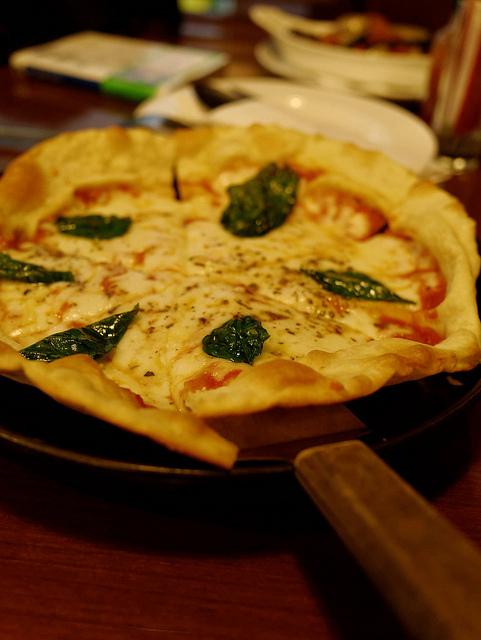Is the background in focus?
Keep it brief. No. Is there spinach on the pizza?
Concise answer only. Yes. What type of food is this?
Be succinct. Pizza. What sole topping is shown on the pizza?
Write a very short answer. Spinach. What toppings are on the pizza?
Quick response, please. Cheese. What does this pizza have on it?
Quick response, please. Spinach. How many vegetables are on the pizza?
Write a very short answer. 1. What color is the plate?
Short answer required. Black. Is this a cartoon drawing?
Answer briefly. No. What does the skillet rest on?
Be succinct. Table. What is the pizza sitting on?
Give a very brief answer. Pan. 